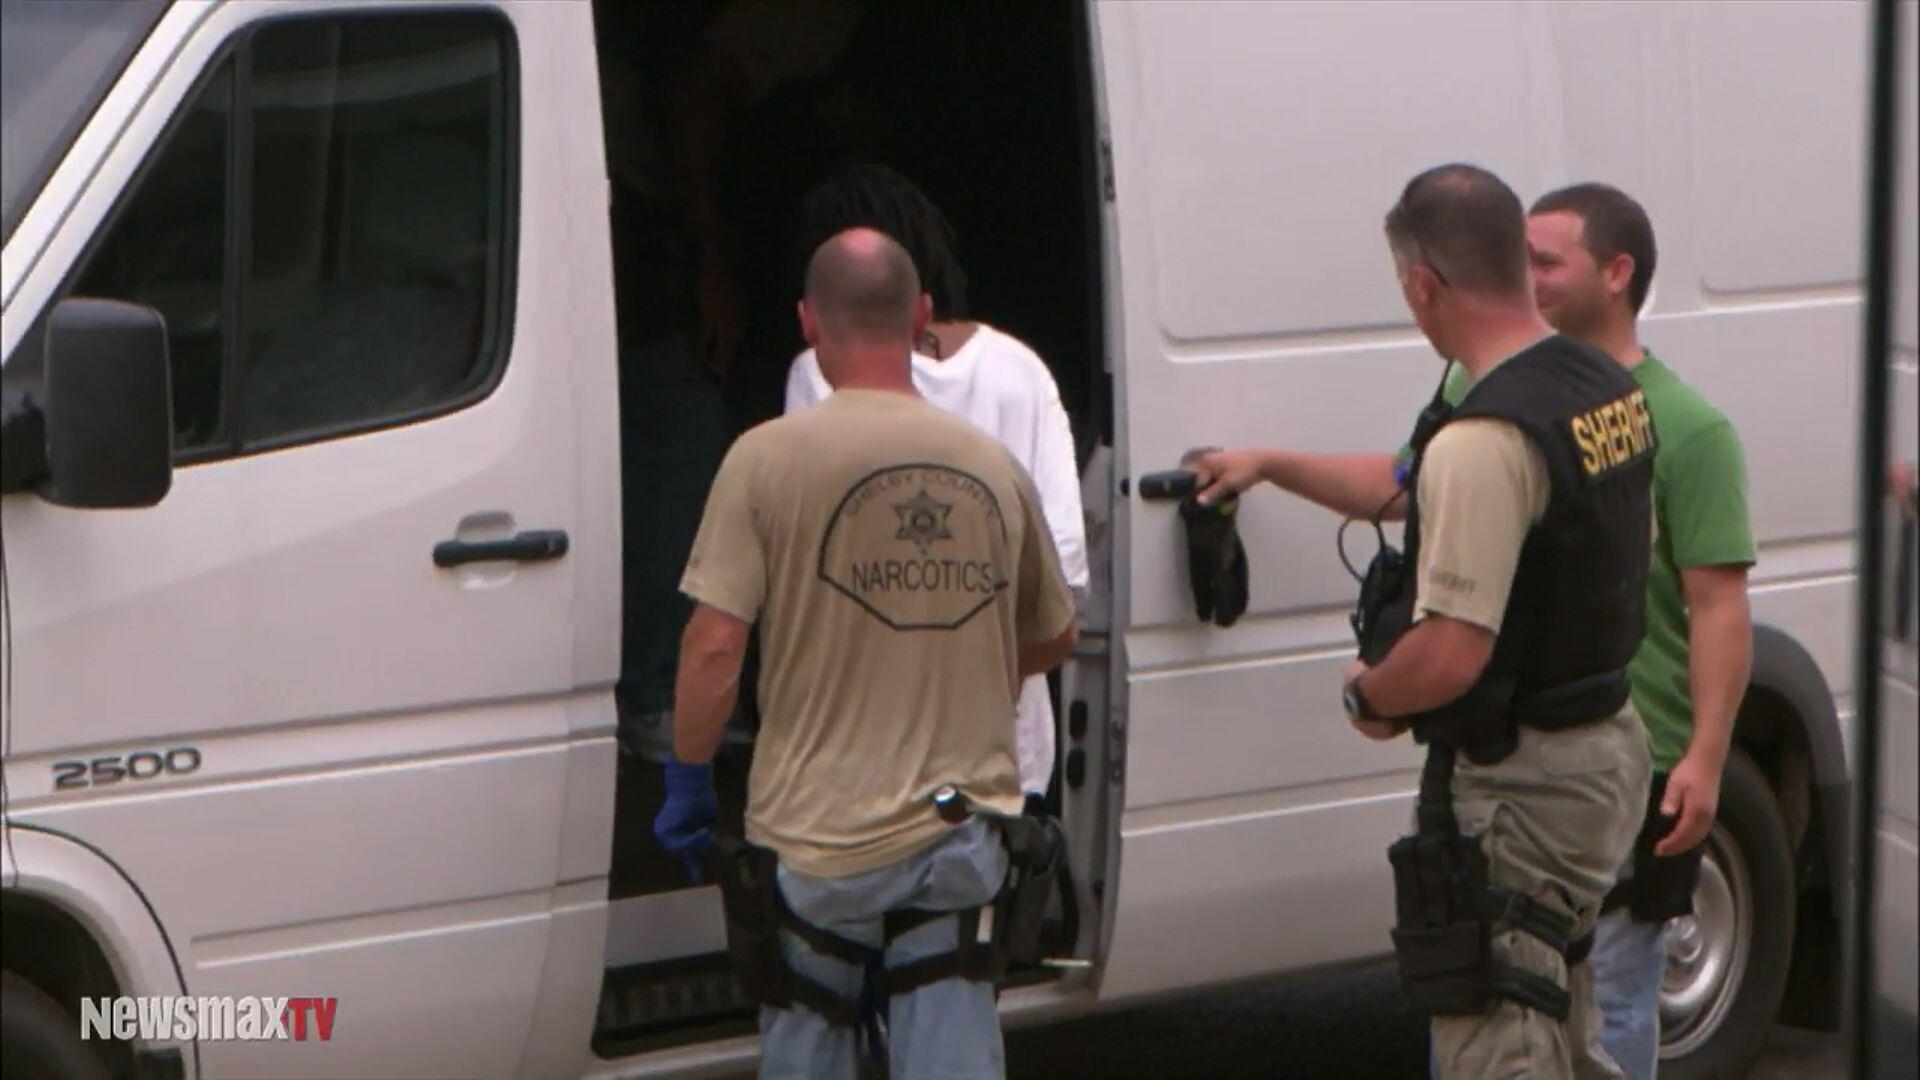What is the news channel name? The news channel name is "newsmax". 